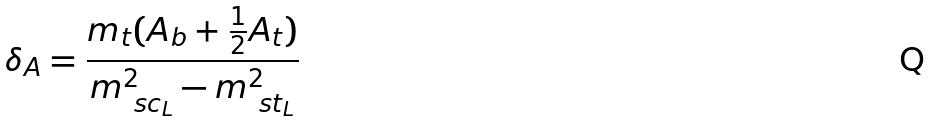<formula> <loc_0><loc_0><loc_500><loc_500>\delta _ { A } = \frac { m _ { t } ( A _ { b } + \frac { 1 } { 2 } A _ { t } ) } { m _ { \ s c _ { L } } ^ { 2 } - m _ { \ s t _ { L } } ^ { 2 } }</formula> 